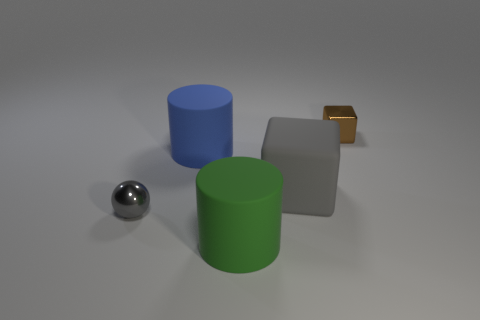Add 3 gray metallic spheres. How many objects exist? 8 Subtract all cylinders. How many objects are left? 3 Add 5 big yellow matte cylinders. How many big yellow matte cylinders exist? 5 Subtract 0 brown cylinders. How many objects are left? 5 Subtract all green metal things. Subtract all gray metallic spheres. How many objects are left? 4 Add 4 brown objects. How many brown objects are left? 5 